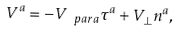<formula> <loc_0><loc_0><loc_500><loc_500>V ^ { a } = - V _ { \ p a r a } \tau ^ { a } + V _ { \perp } n ^ { a } ,</formula> 